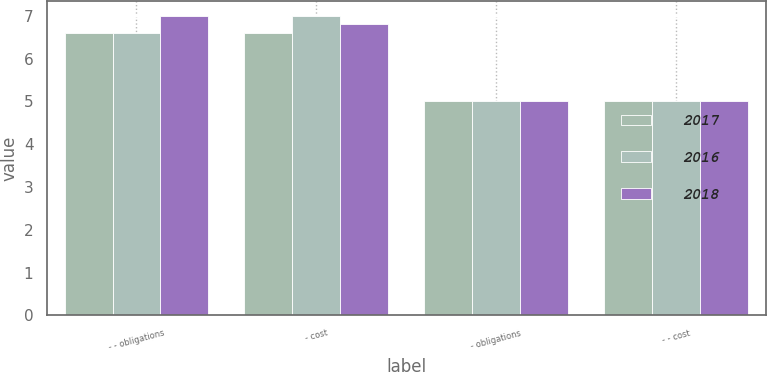Convert chart to OTSL. <chart><loc_0><loc_0><loc_500><loc_500><stacked_bar_chart><ecel><fcel>- - obligations<fcel>- cost<fcel>- obligations<fcel>- - cost<nl><fcel>2017<fcel>6.6<fcel>6.6<fcel>5<fcel>5<nl><fcel>2016<fcel>6.6<fcel>7<fcel>5<fcel>5<nl><fcel>2018<fcel>7<fcel>6.8<fcel>5<fcel>5<nl></chart> 